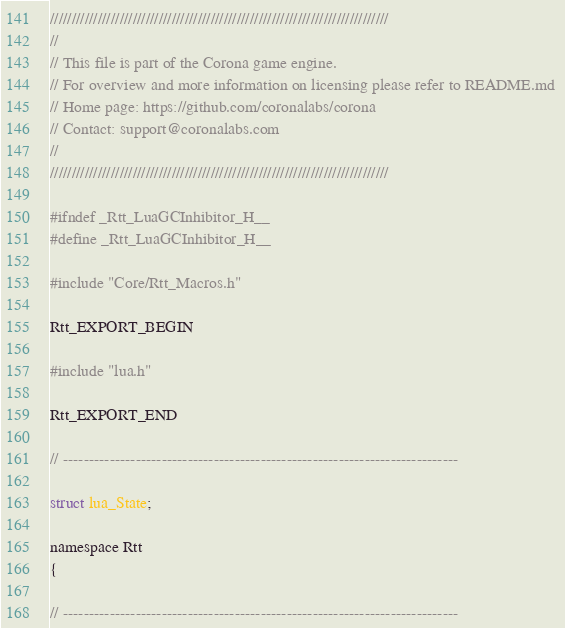<code> <loc_0><loc_0><loc_500><loc_500><_C_>//////////////////////////////////////////////////////////////////////////////
//
// This file is part of the Corona game engine.
// For overview and more information on licensing please refer to README.md 
// Home page: https://github.com/coronalabs/corona
// Contact: support@coronalabs.com
//
//////////////////////////////////////////////////////////////////////////////

#ifndef _Rtt_LuaGCInhibitor_H__
#define _Rtt_LuaGCInhibitor_H__

#include "Core/Rtt_Macros.h"

Rtt_EXPORT_BEGIN

#include "lua.h"

Rtt_EXPORT_END

// ----------------------------------------------------------------------------

struct lua_State;

namespace Rtt
{

// ----------------------------------------------------------------------------
</code> 